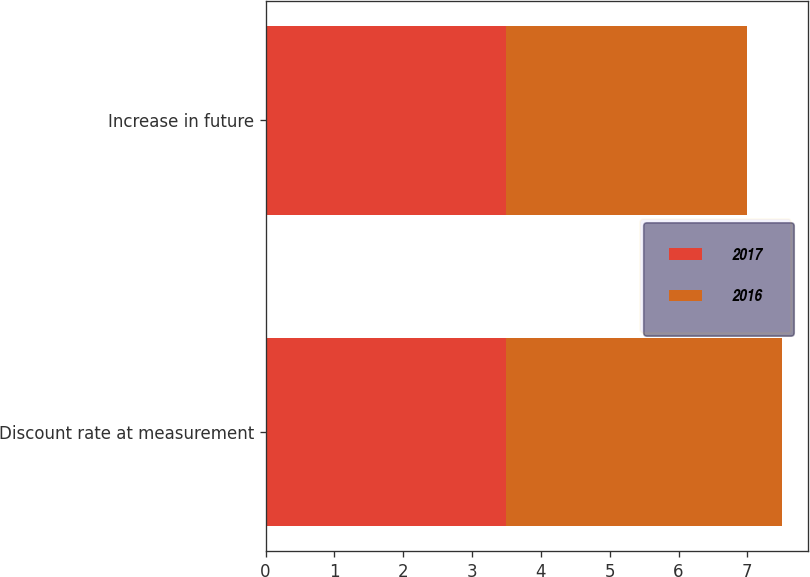Convert chart. <chart><loc_0><loc_0><loc_500><loc_500><stacked_bar_chart><ecel><fcel>Discount rate at measurement<fcel>Increase in future<nl><fcel>2017<fcel>3.5<fcel>3.5<nl><fcel>2016<fcel>4<fcel>3.5<nl></chart> 